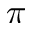Convert formula to latex. <formula><loc_0><loc_0><loc_500><loc_500>\pi</formula> 